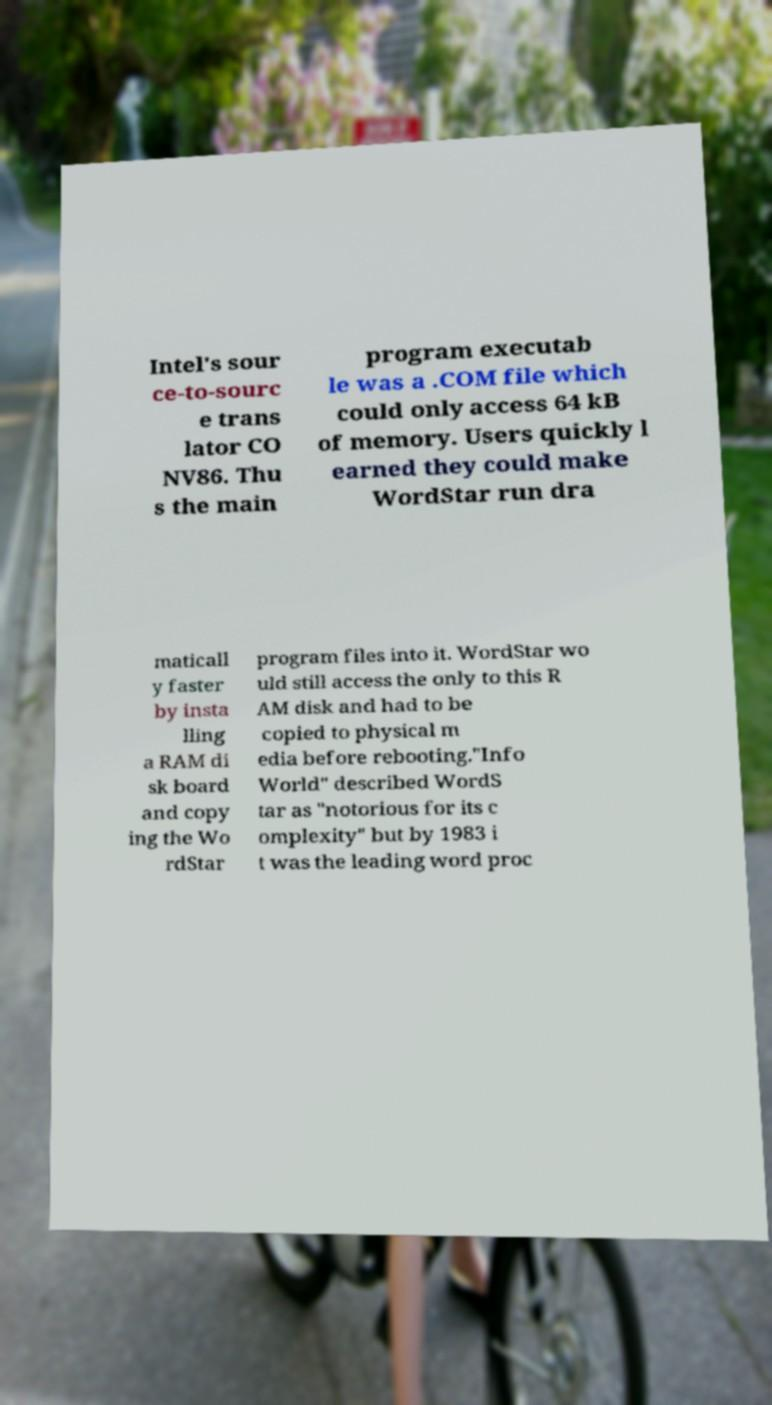Can you accurately transcribe the text from the provided image for me? Intel's sour ce-to-sourc e trans lator CO NV86. Thu s the main program executab le was a .COM file which could only access 64 kB of memory. Users quickly l earned they could make WordStar run dra maticall y faster by insta lling a RAM di sk board and copy ing the Wo rdStar program files into it. WordStar wo uld still access the only to this R AM disk and had to be copied to physical m edia before rebooting."Info World" described WordS tar as "notorious for its c omplexity" but by 1983 i t was the leading word proc 